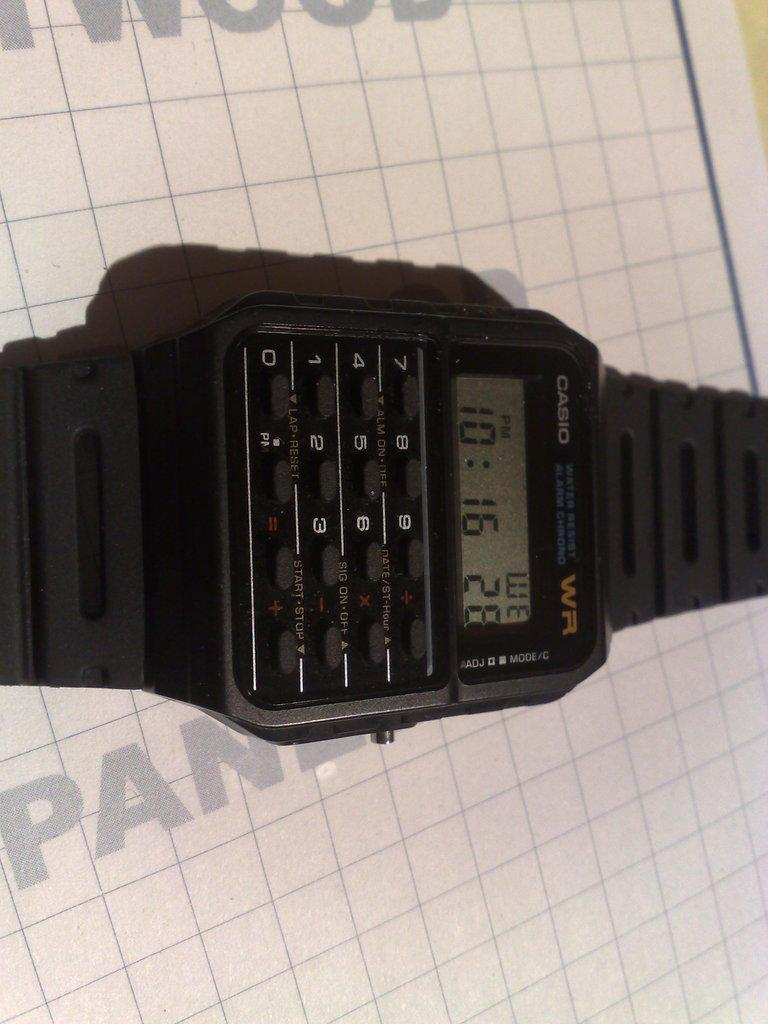Provide a one-sentence caption for the provided image. An older CASIO brand watch with a calculator on it. 